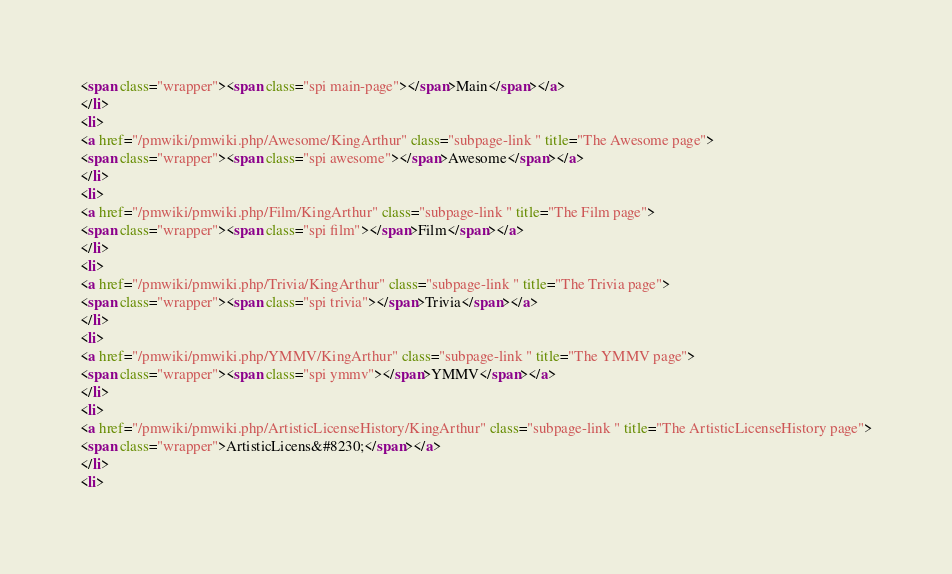<code> <loc_0><loc_0><loc_500><loc_500><_HTML_><span class="wrapper"><span class="spi main-page"></span>Main</span></a>
</li>
<li>
<a href="/pmwiki/pmwiki.php/Awesome/KingArthur" class="subpage-link " title="The Awesome page">
<span class="wrapper"><span class="spi awesome"></span>Awesome</span></a>
</li>
<li>
<a href="/pmwiki/pmwiki.php/Film/KingArthur" class="subpage-link " title="The Film page">
<span class="wrapper"><span class="spi film"></span>Film</span></a>
</li>
<li>
<a href="/pmwiki/pmwiki.php/Trivia/KingArthur" class="subpage-link " title="The Trivia page">
<span class="wrapper"><span class="spi trivia"></span>Trivia</span></a>
</li>
<li>
<a href="/pmwiki/pmwiki.php/YMMV/KingArthur" class="subpage-link " title="The YMMV page">
<span class="wrapper"><span class="spi ymmv"></span>YMMV</span></a>
</li>
<li>
<a href="/pmwiki/pmwiki.php/ArtisticLicenseHistory/KingArthur" class="subpage-link " title="The ArtisticLicenseHistory page">
<span class="wrapper">ArtisticLicens&#8230;</span></a>
</li>
<li></code> 